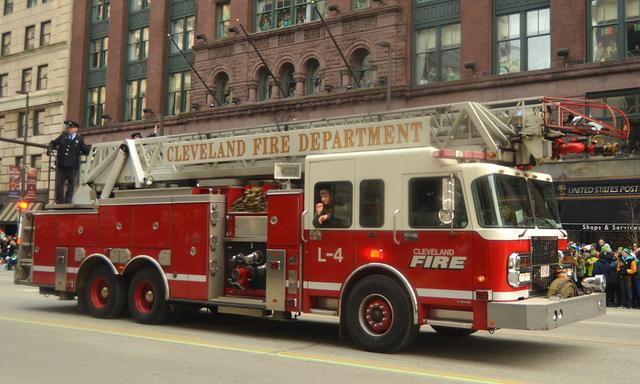Do you see firemen in the truck?
Give a very brief answer. Yes. What is the color of the fire truck?
Give a very brief answer. Red. What is the number of this fire truck?
Concise answer only. L-4. What city is the fire truck from?
Concise answer only. Cleveland. What is the truck number?
Write a very short answer. L-4. 